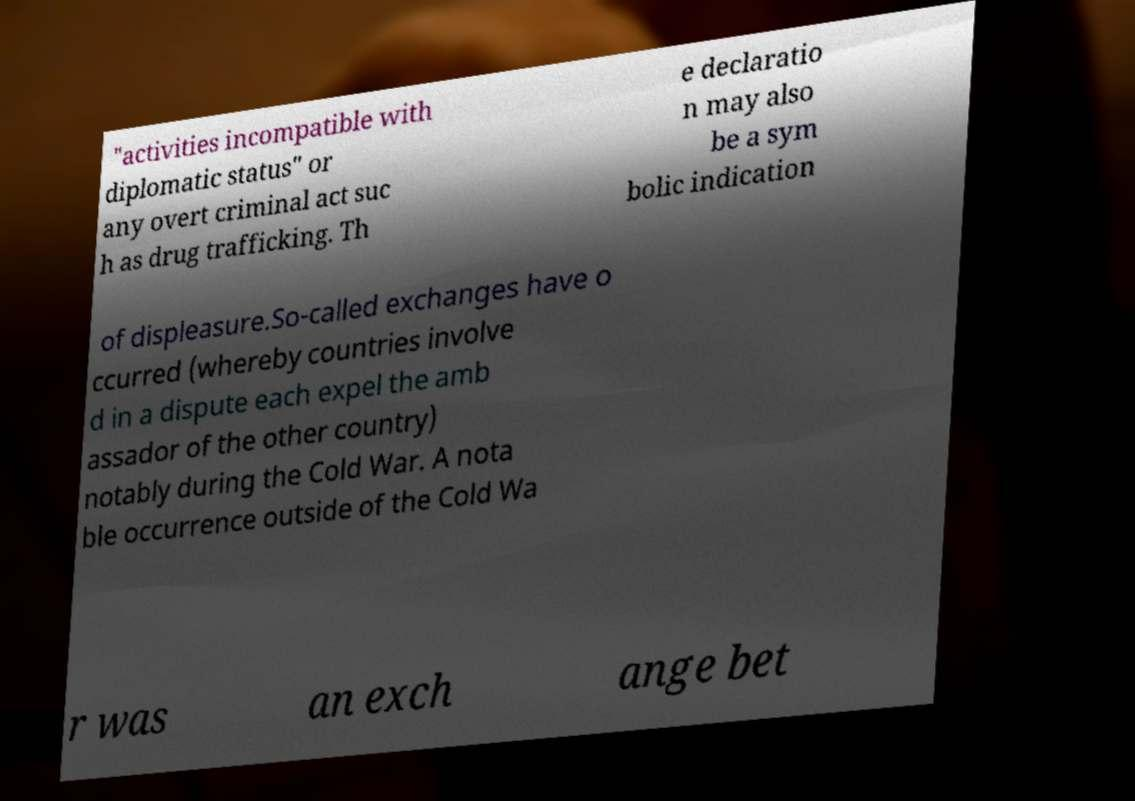For documentation purposes, I need the text within this image transcribed. Could you provide that? "activities incompatible with diplomatic status" or any overt criminal act suc h as drug trafficking. Th e declaratio n may also be a sym bolic indication of displeasure.So-called exchanges have o ccurred (whereby countries involve d in a dispute each expel the amb assador of the other country) notably during the Cold War. A nota ble occurrence outside of the Cold Wa r was an exch ange bet 